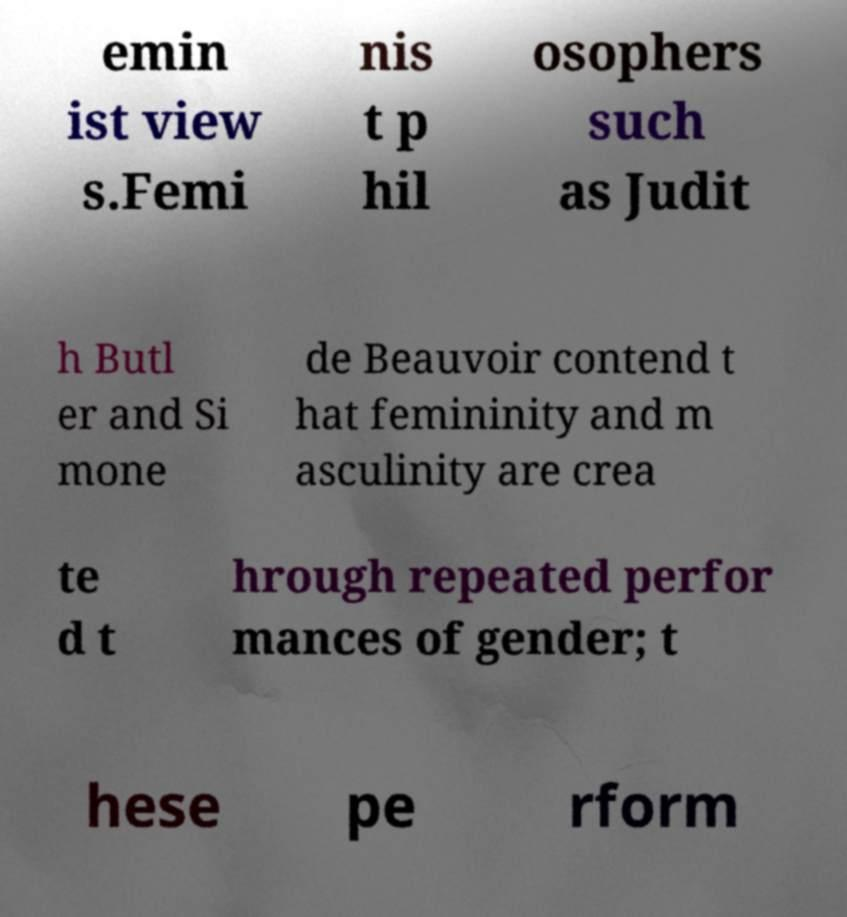There's text embedded in this image that I need extracted. Can you transcribe it verbatim? emin ist view s.Femi nis t p hil osophers such as Judit h Butl er and Si mone de Beauvoir contend t hat femininity and m asculinity are crea te d t hrough repeated perfor mances of gender; t hese pe rform 